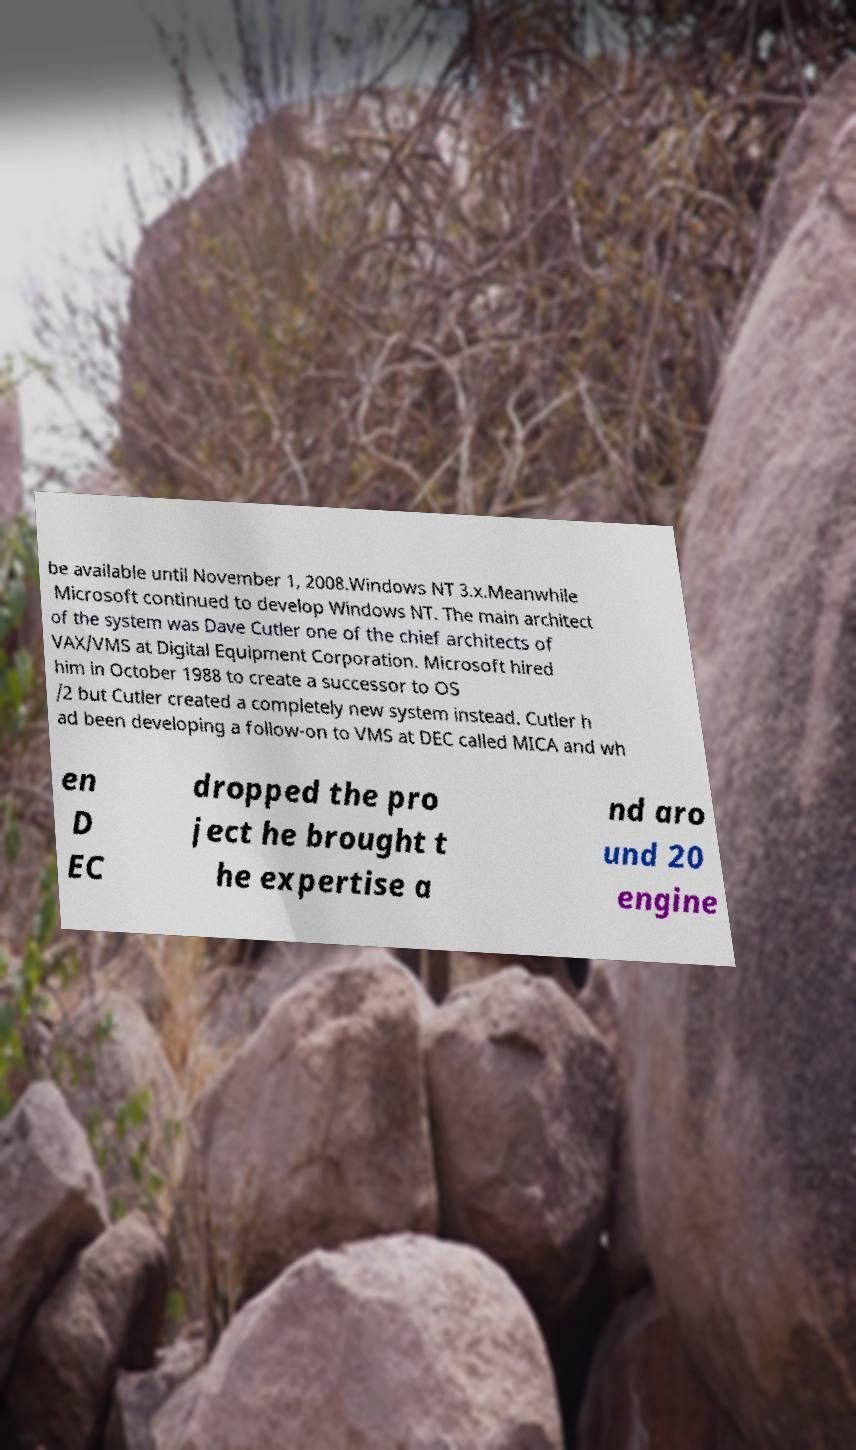Can you read and provide the text displayed in the image?This photo seems to have some interesting text. Can you extract and type it out for me? be available until November 1, 2008.Windows NT 3.x.Meanwhile Microsoft continued to develop Windows NT. The main architect of the system was Dave Cutler one of the chief architects of VAX/VMS at Digital Equipment Corporation. Microsoft hired him in October 1988 to create a successor to OS /2 but Cutler created a completely new system instead. Cutler h ad been developing a follow-on to VMS at DEC called MICA and wh en D EC dropped the pro ject he brought t he expertise a nd aro und 20 engine 